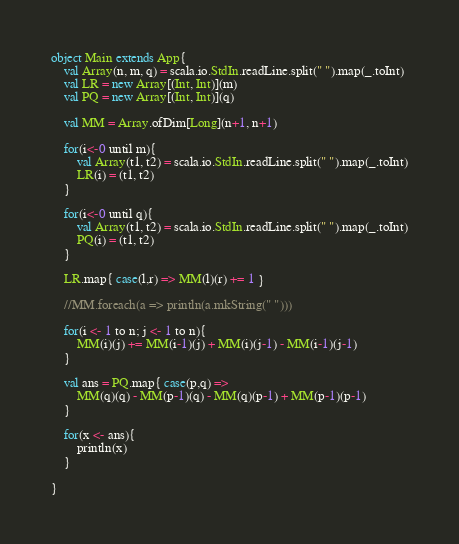<code> <loc_0><loc_0><loc_500><loc_500><_Scala_>object Main extends App{
    val Array(n, m, q) = scala.io.StdIn.readLine.split(" ").map(_.toInt)
    val LR = new Array[(Int, Int)](m)
    val PQ = new Array[(Int, Int)](q)

    val MM = Array.ofDim[Long](n+1, n+1)

    for(i<-0 until m){
    	val Array(t1, t2) = scala.io.StdIn.readLine.split(" ").map(_.toInt)
    	LR(i) = (t1, t2)
    }

    for(i<-0 until q){
    	val Array(t1, t2) = scala.io.StdIn.readLine.split(" ").map(_.toInt)
    	PQ(i) = (t1, t2)
    }

    LR.map{ case(l,r) => MM(l)(r) += 1 }

    //MM.foreach(a => println(a.mkString(" ")))

    for(i <- 1 to n; j <- 1 to n){
    	MM(i)(j) += MM(i-1)(j) + MM(i)(j-1) - MM(i-1)(j-1)
    }

    val ans = PQ.map{ case(p,q) => 
		MM(q)(q) - MM(p-1)(q) - MM(q)(p-1) + MM(p-1)(p-1)		
	}

	for(x <- ans){
		println(x)
	}

}</code> 